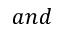<formula> <loc_0><loc_0><loc_500><loc_500>a n d</formula> 